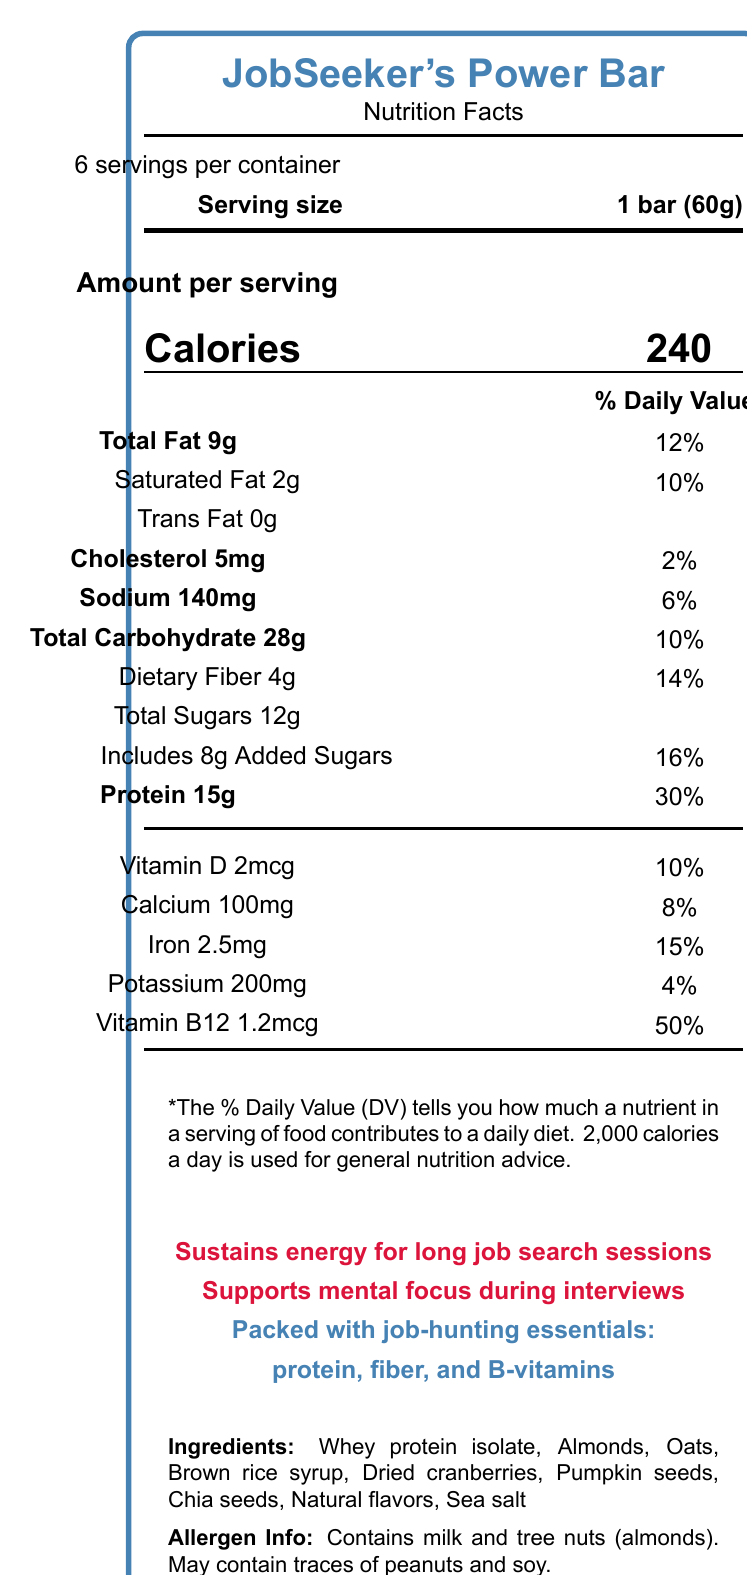What is the serving size of JobSeeker's Power Bar? The serving size is listed at the top of the document as "Serving size: 1 bar (60g)".
Answer: 1 bar (60g) How many servings are there per container? The document states that there are "6 servings per container."
Answer: 6 How many calories are in one serving of JobSeeker's Power Bar? The number of calories per serving is listed as "Calories: 240".
Answer: 240 What percentage of the daily value is provided by the protein in one serving of JobSeeker's Power Bar? The protein amount is provided as "Protein 15g" and it's marked as 30% of the daily value.
Answer: 30% Which allergens are contained in JobSeeker's Power Bar? The allergen information section lists the contents as "Contains milk and tree nuts (almonds). May contain traces of peanuts and soy."
Answer: Milk and tree nuts (almonds) Is there any trans fat in JobSeeker's Power Bar? The document specifies "Trans Fat 0g," indicating there is no trans fat in the product.
Answer: No How long should you consume the JobSeeker's Power Bar after opening it? The storage instructions state to "Consume within 7 days of opening."
Answer: Within 7 days What is the main vitamin provided in JobSeeker's Power Bar, which supports mental focus during interviews? Under the vitamins section, Vitamin B12 is provided at 1.2mcg (50% DV), and one of the marketing claims is "Supports mental focus during interviews."
Answer: Vitamin B12 What are the main sources of carbohydrates in the JobSeeker's Power Bar as listed in the ingredients? The ingredients include "Oats" and "Brown rice syrup", both common sources of carbohydrates.
Answer: Oats and brown rice syrup What should your estimated daily calorie intake be to use the % Daily Value as a reference? The footnote states, "2,000 calories a day is used for general nutrition advice."
Answer: 2,000 calories Which of the following claims is made about JobSeeker's Power Bar? A. Helps in weight loss B. Provides sustained energy C. Lowers cholesterol D. Gluten-free The marketing claims include "Sustains energy for long job search sessions."
Answer: B What ingredient is not listed in the ingredients section? A. Almonds B. Oats C. Soy D. Sea salt "Soy" is not listed in the ingredients section, though the allergen info states it may contain traces of soy.
Answer: C Does JobSeeker's Power Bar contain iron? The document lists "Iron 2.5mg (15%)", confirming that it contains iron.
Answer: Yes Summarize the main idea of the document. The document includes all necessary details for understanding the nutritional value and intended benefits of the JobSeeker's Power Bar. It emphasizes the high protein content, essential vitamins, and suitability for sustained energy during high-focus activities like job searching.
Answer: The document describes the nutritional facts for JobSeeker's Power Bar, a protein-packed snack designed to sustain energy and support mental focus. It provides detailed information on serving size, calories, nutrient amounts, ingredients, allergens, and various marketing claims. The product is aimed at helping individuals maintain energy levels during long job search sessions. How much magnesium does JobSeeker's Power Bar contain? The document does not provide any information about magnesium content.
Answer: Not enough information 